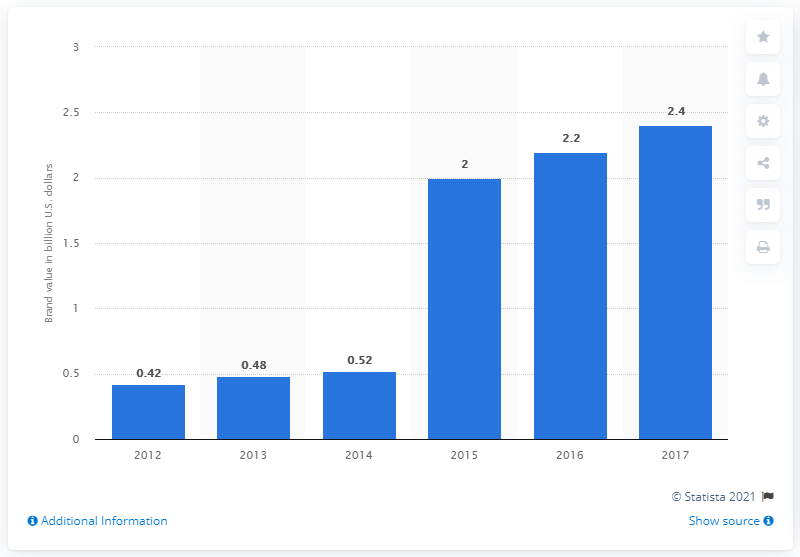Highlight a few significant elements in this photo. In 2017, MLBAM's brand value was estimated to be approximately 2.4 billion dollars. 